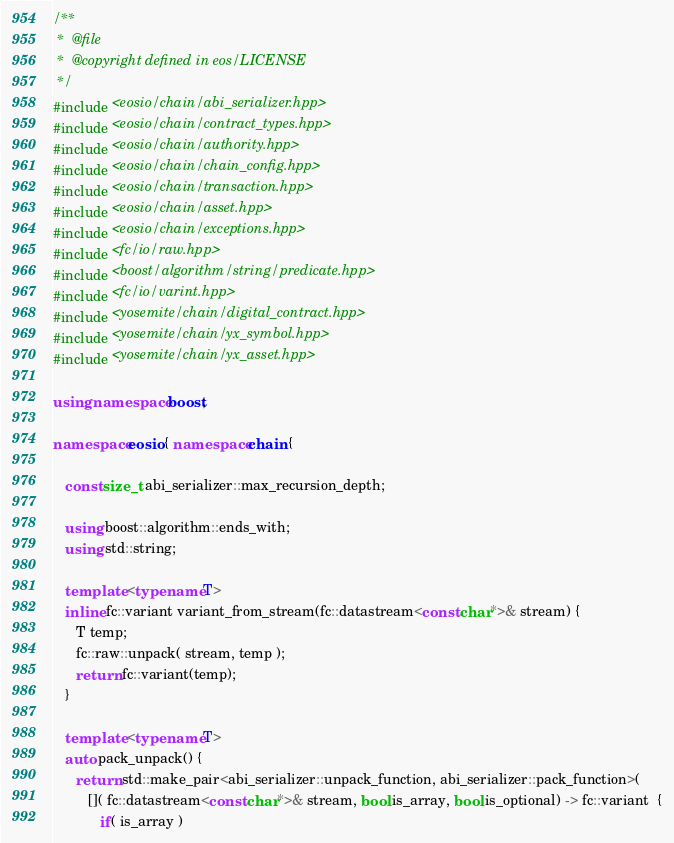<code> <loc_0><loc_0><loc_500><loc_500><_C++_>/**
 *  @file
 *  @copyright defined in eos/LICENSE
 */
#include <eosio/chain/abi_serializer.hpp>
#include <eosio/chain/contract_types.hpp>
#include <eosio/chain/authority.hpp>
#include <eosio/chain/chain_config.hpp>
#include <eosio/chain/transaction.hpp>
#include <eosio/chain/asset.hpp>
#include <eosio/chain/exceptions.hpp>
#include <fc/io/raw.hpp>
#include <boost/algorithm/string/predicate.hpp>
#include <fc/io/varint.hpp>
#include <yosemite/chain/digital_contract.hpp>
#include <yosemite/chain/yx_symbol.hpp>
#include <yosemite/chain/yx_asset.hpp>

using namespace boost;

namespace eosio { namespace chain {

   const size_t abi_serializer::max_recursion_depth;

   using boost::algorithm::ends_with;
   using std::string;

   template <typename T>
   inline fc::variant variant_from_stream(fc::datastream<const char*>& stream) {
      T temp;
      fc::raw::unpack( stream, temp );
      return fc::variant(temp);
   }

   template <typename T>
   auto pack_unpack() {
      return std::make_pair<abi_serializer::unpack_function, abi_serializer::pack_function>(
         []( fc::datastream<const char*>& stream, bool is_array, bool is_optional) -> fc::variant  {
            if( is_array )</code> 